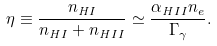<formula> <loc_0><loc_0><loc_500><loc_500>\eta \equiv \frac { n _ { \mathit H I } } { n _ { \mathit H I } + n _ { \mathit H I I } } \simeq \frac { \alpha _ { \mathit H I I } n _ { e } } { \Gamma _ { \gamma } } .</formula> 